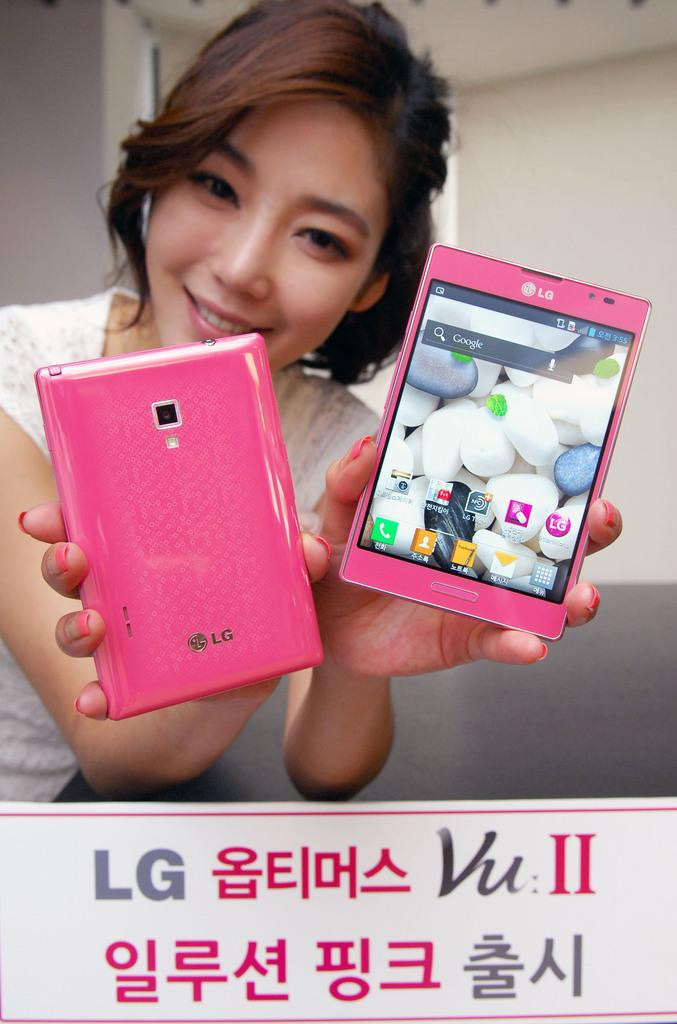<image>
Create a compact narrative representing the image presented. A girl is holding up two bright pink LG phones and one shows the time as 3:55. 